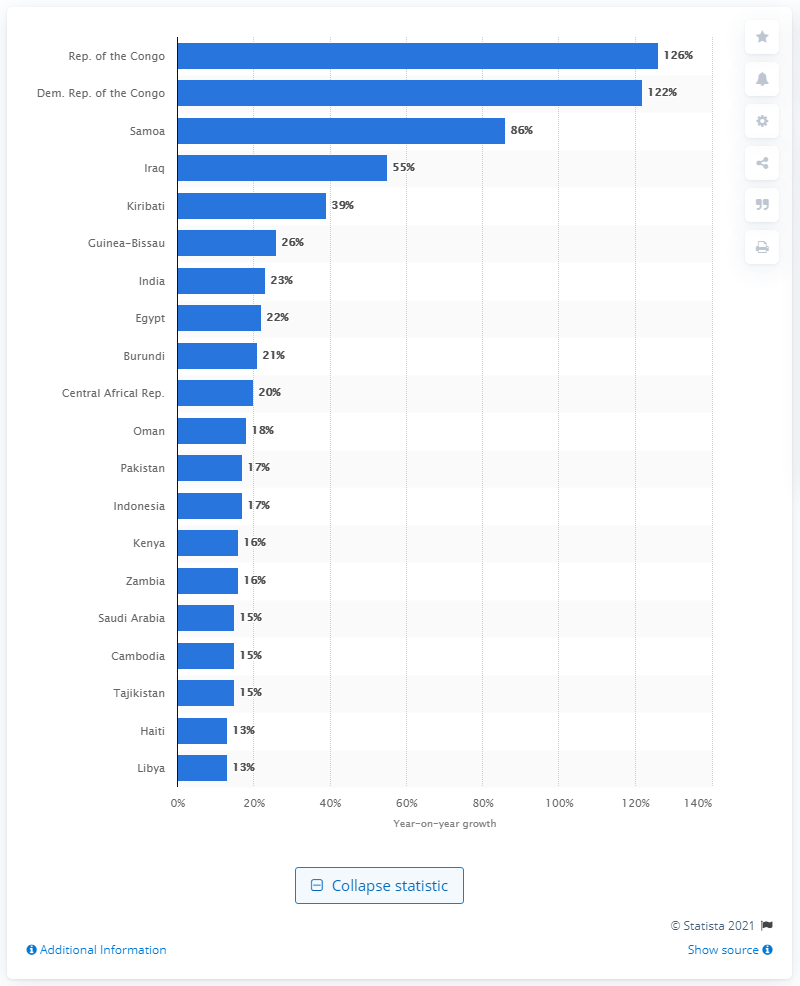Mention a couple of crucial points in this snapshot. Online audiences in the Republic of the Congo grew in total by 126%. 